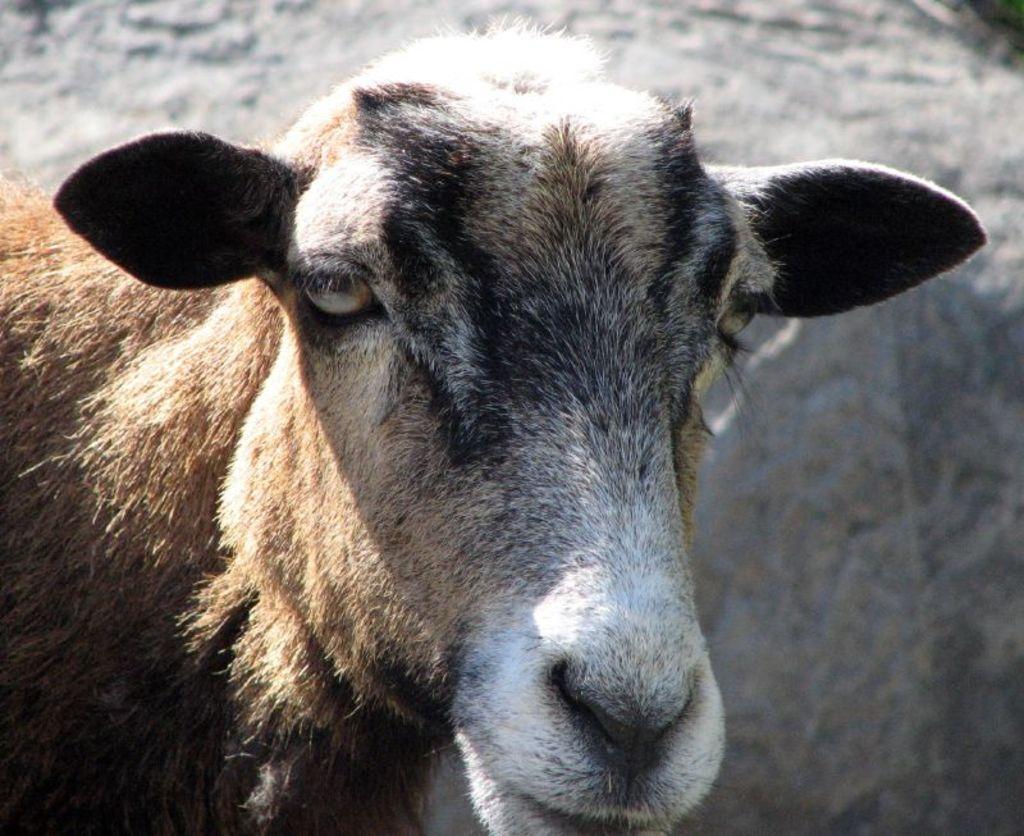Please provide a concise description of this image. In this image we can see an animal. In the background, we can see the wall. 